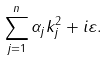Convert formula to latex. <formula><loc_0><loc_0><loc_500><loc_500>\sum _ { j = 1 } ^ { n } \alpha _ { j } k _ { j } ^ { 2 } + i \varepsilon .</formula> 